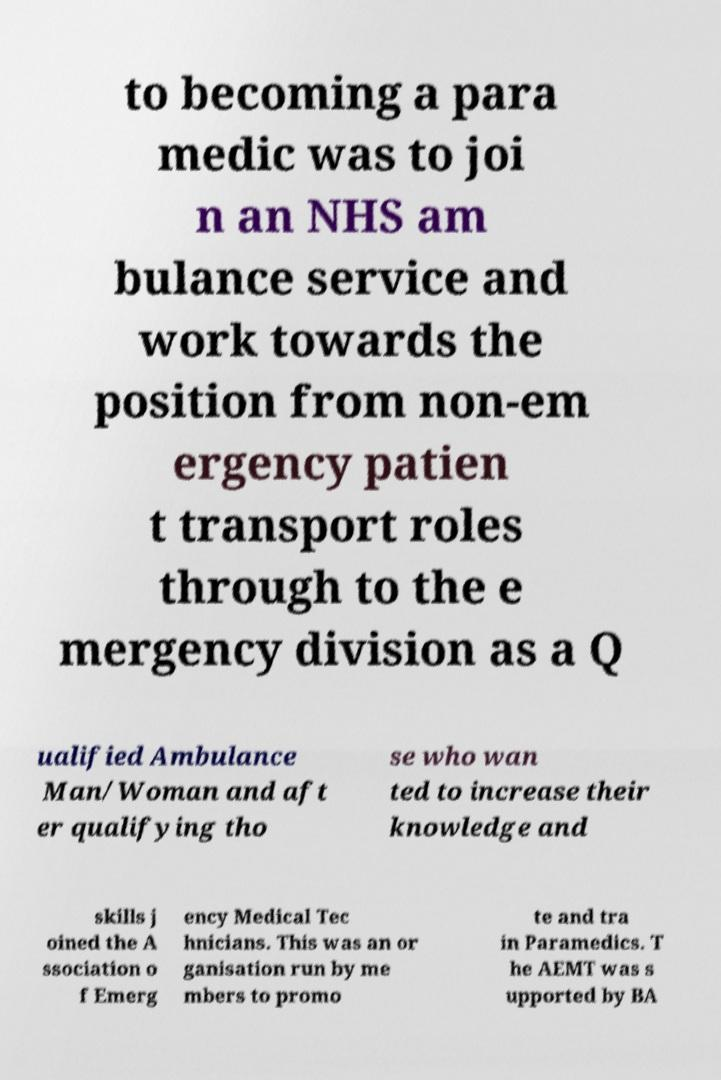For documentation purposes, I need the text within this image transcribed. Could you provide that? to becoming a para medic was to joi n an NHS am bulance service and work towards the position from non-em ergency patien t transport roles through to the e mergency division as a Q ualified Ambulance Man/Woman and aft er qualifying tho se who wan ted to increase their knowledge and skills j oined the A ssociation o f Emerg ency Medical Tec hnicians. This was an or ganisation run by me mbers to promo te and tra in Paramedics. T he AEMT was s upported by BA 